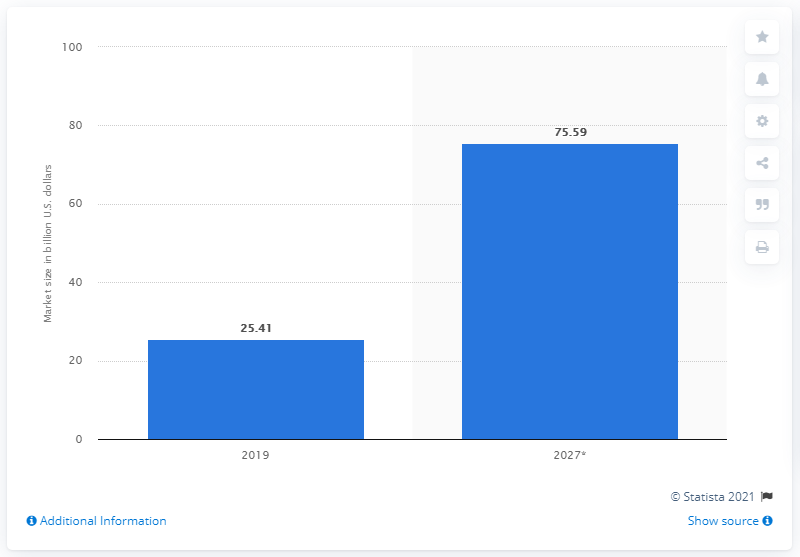Mention a couple of crucial points in this snapshot. The global VPN market is projected to reach $75.59 billion by 2027. 